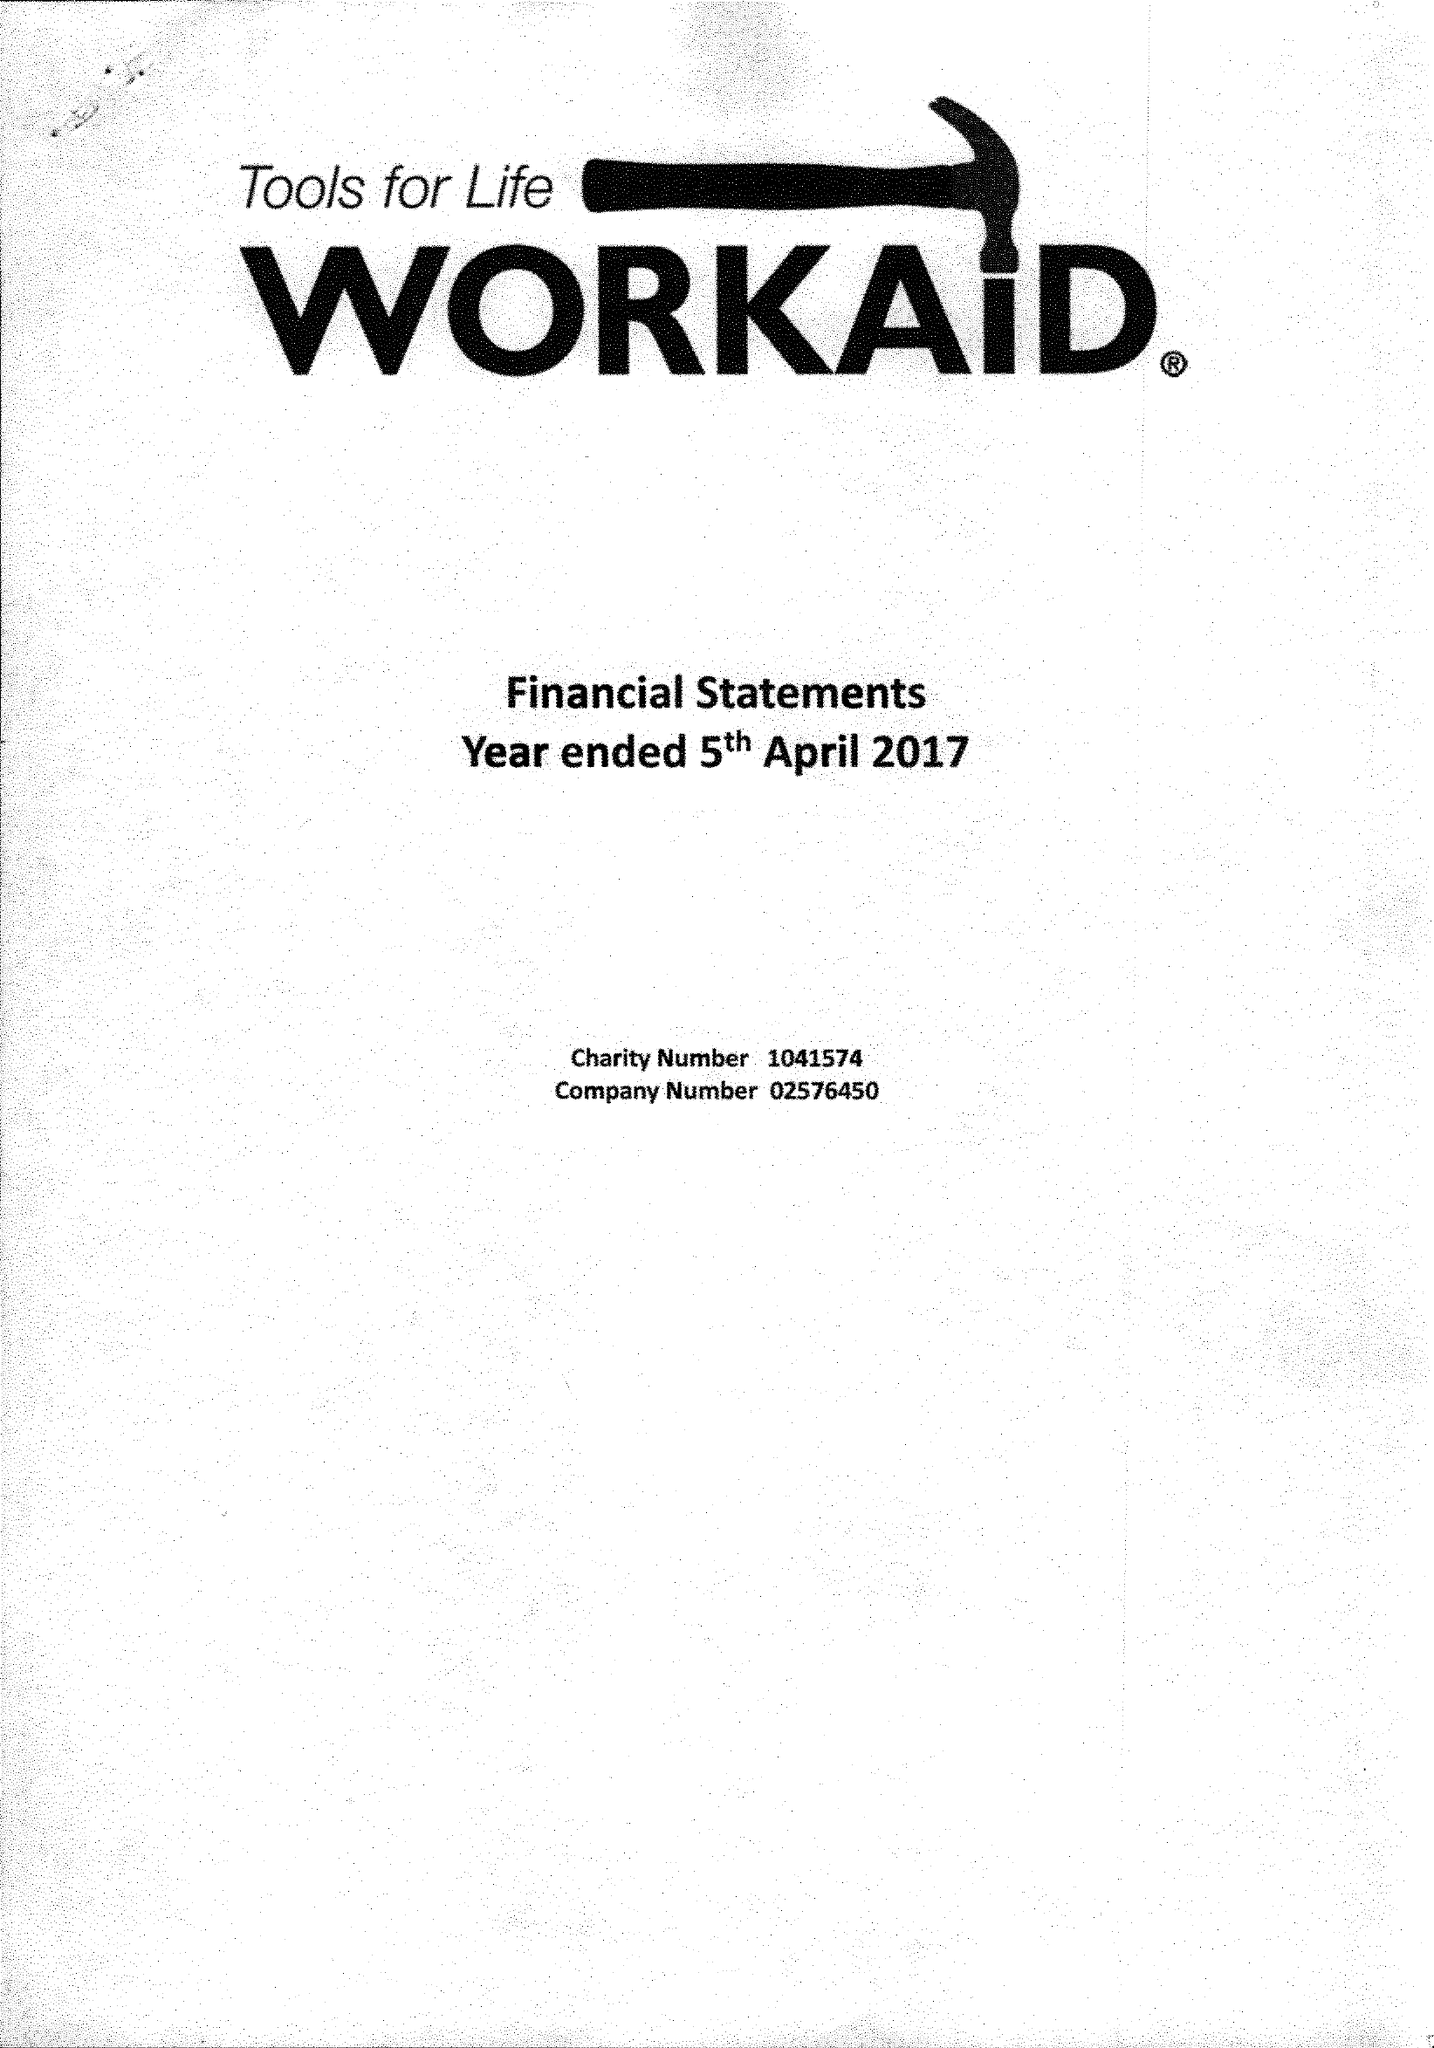What is the value for the charity_name?
Answer the question using a single word or phrase. Workaid 